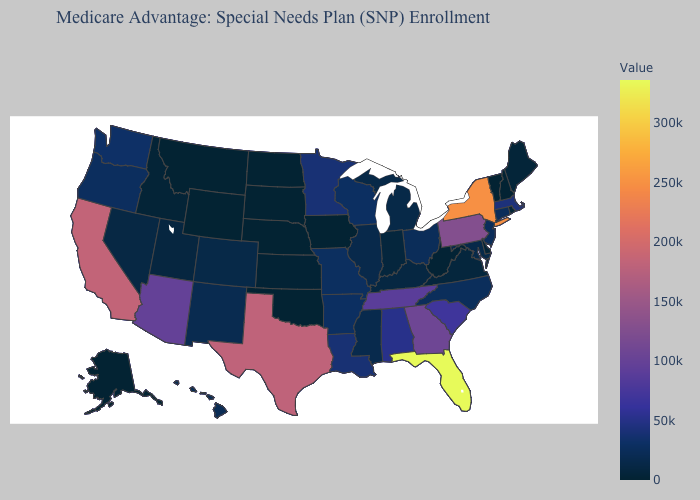Does Massachusetts have a lower value than Montana?
Concise answer only. No. Among the states that border Delaware , does Maryland have the lowest value?
Short answer required. Yes. Does Montana have a higher value than Florida?
Short answer required. No. 